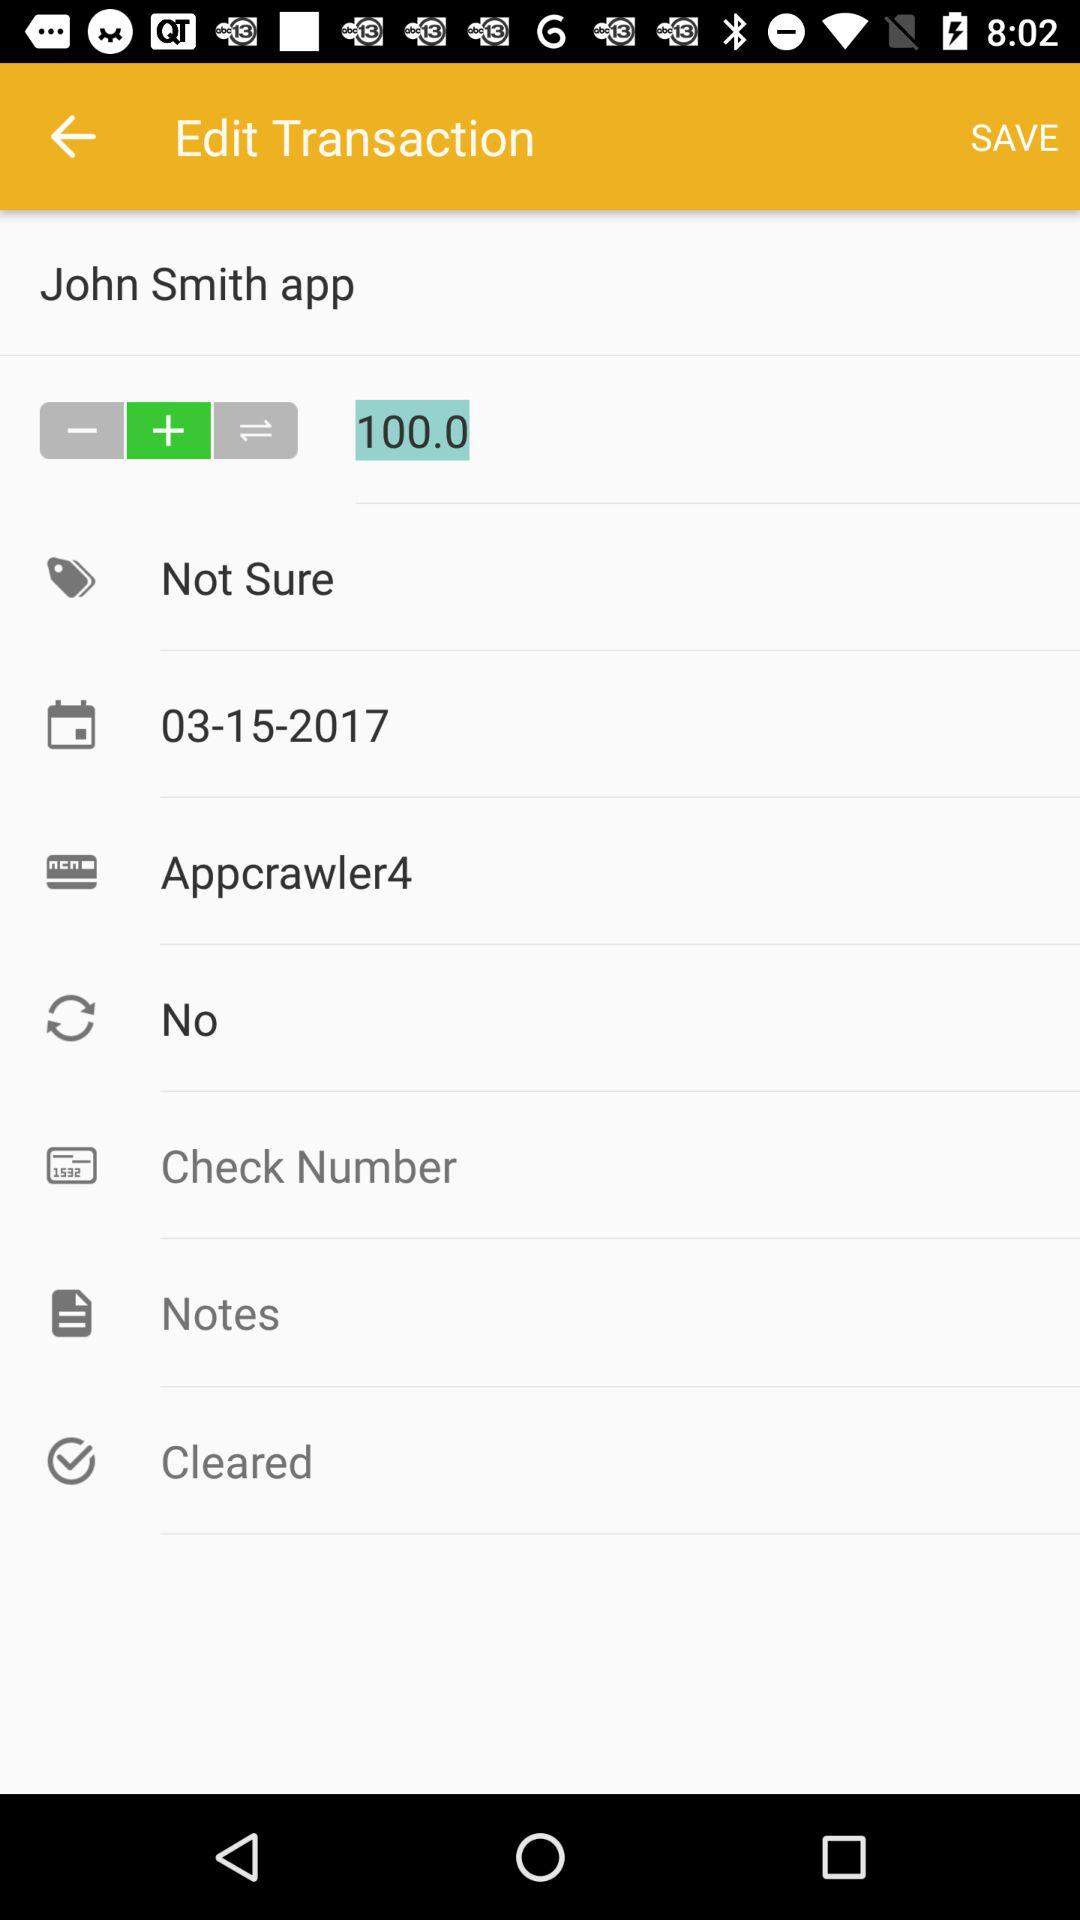What is the date of this transaction?
Answer the question using a single word or phrase. 03-15-2017 